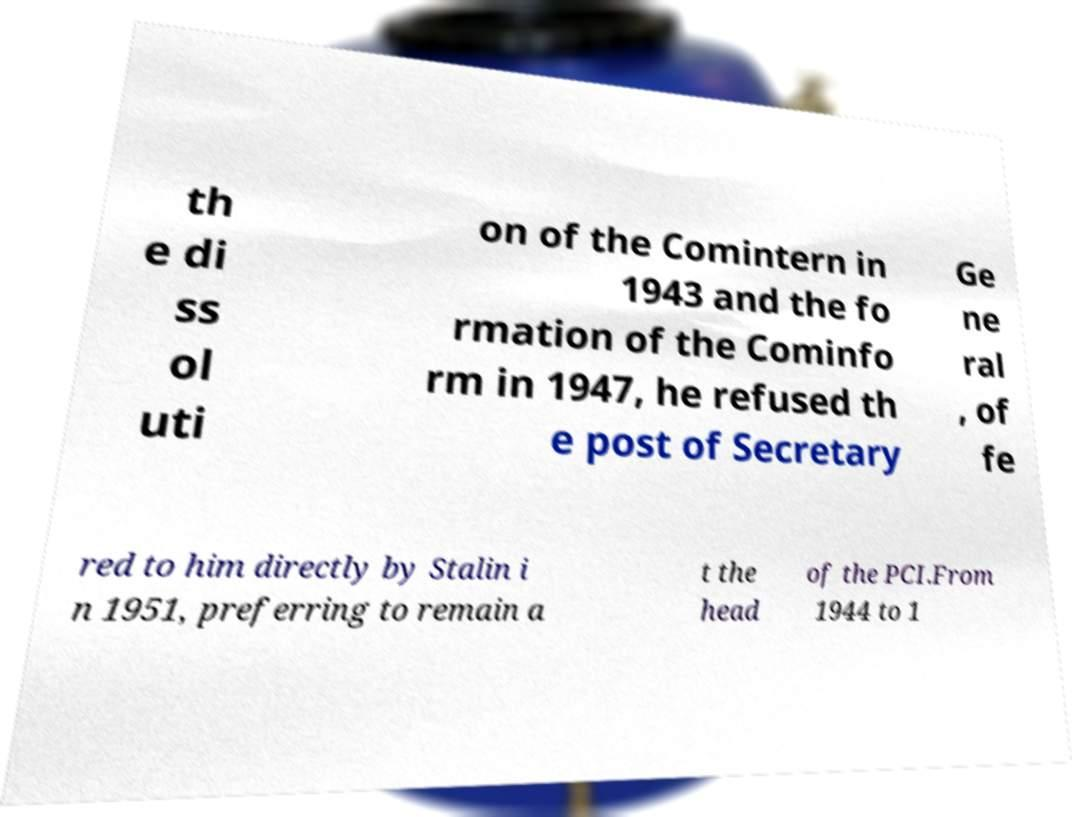I need the written content from this picture converted into text. Can you do that? th e di ss ol uti on of the Comintern in 1943 and the fo rmation of the Cominfo rm in 1947, he refused th e post of Secretary Ge ne ral , of fe red to him directly by Stalin i n 1951, preferring to remain a t the head of the PCI.From 1944 to 1 